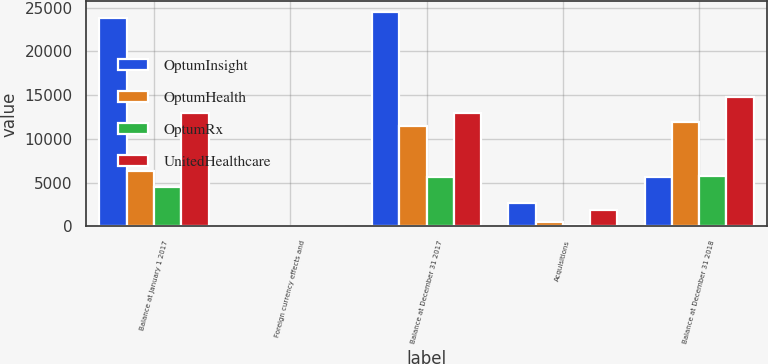Convert chart to OTSL. <chart><loc_0><loc_0><loc_500><loc_500><stacked_bar_chart><ecel><fcel>Balance at January 1 2017<fcel>Foreign currency effects and<fcel>Balance at December 31 2017<fcel>Acquisitions<fcel>Balance at December 31 2018<nl><fcel>OptumInsight<fcel>23854<fcel>60<fcel>24484<fcel>2723<fcel>5674<nl><fcel>OptumHealth<fcel>6322<fcel>23<fcel>11488<fcel>471<fcel>11947<nl><fcel>OptumRx<fcel>4449<fcel>4<fcel>5674<fcel>106<fcel>5772<nl><fcel>UnitedHealthcare<fcel>12959<fcel>49<fcel>12910<fcel>1881<fcel>14791<nl></chart> 